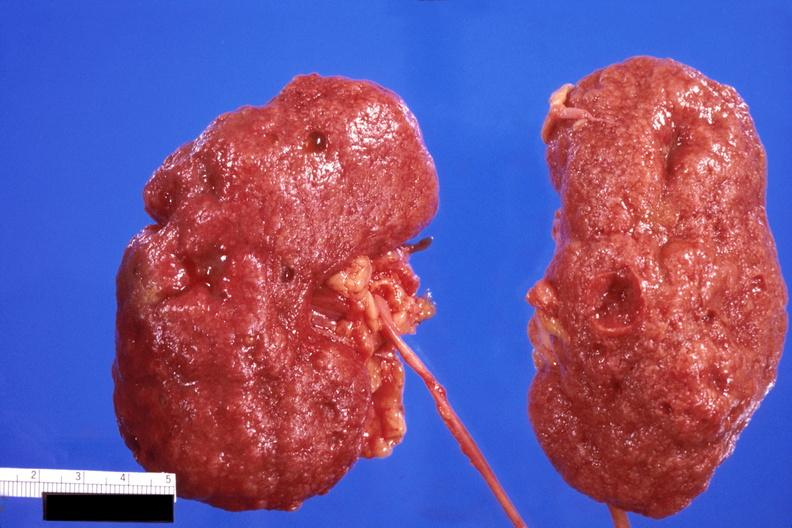does close-up tumor show kidney, cortical scarring from diabetes mellitus?
Answer the question using a single word or phrase. No 